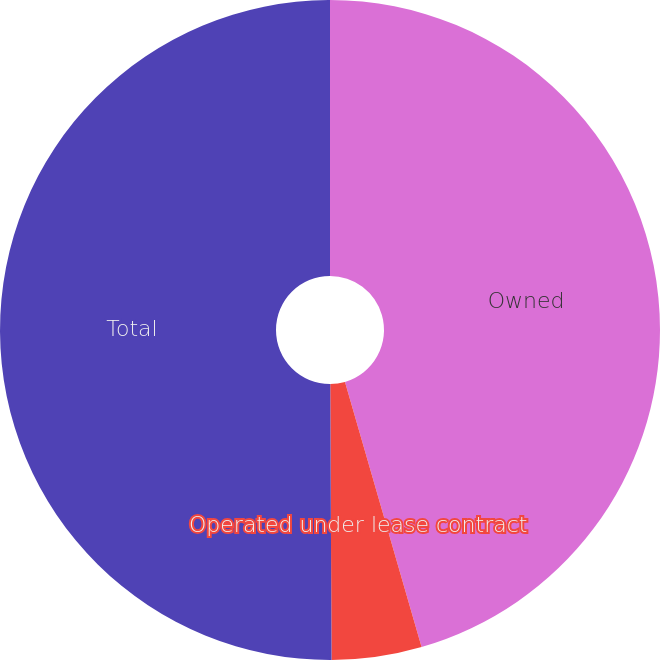Convert chart to OTSL. <chart><loc_0><loc_0><loc_500><loc_500><pie_chart><fcel>Owned<fcel>Operated under lease contract<fcel>Total<nl><fcel>45.52%<fcel>4.4%<fcel>50.07%<nl></chart> 